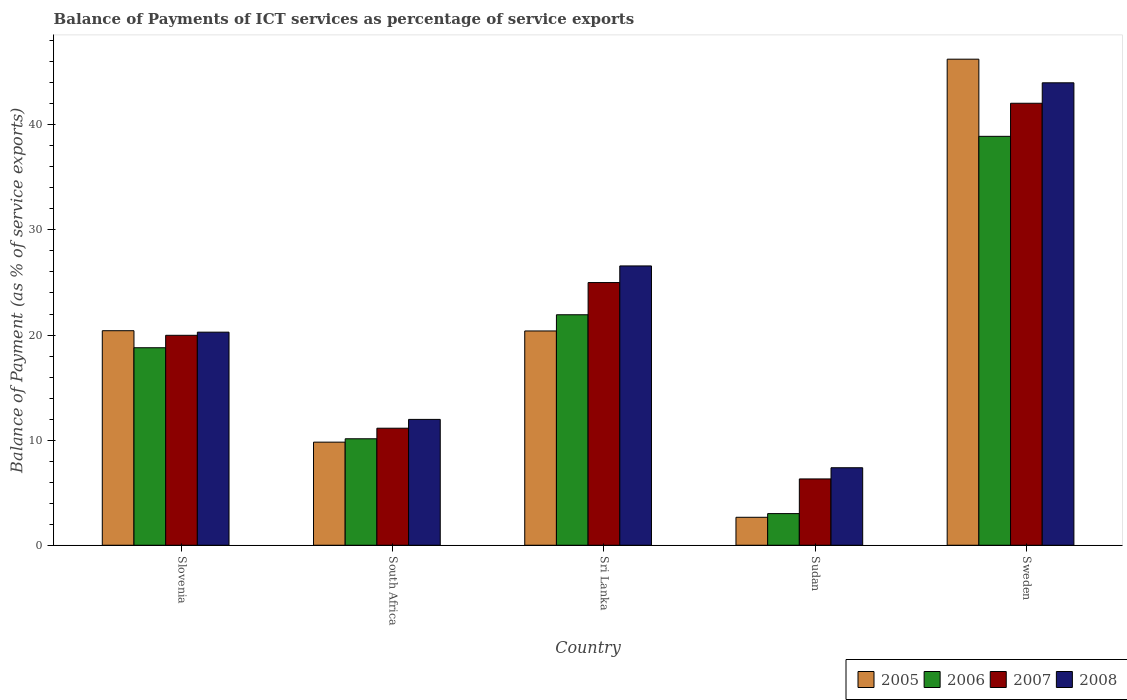Are the number of bars on each tick of the X-axis equal?
Ensure brevity in your answer.  Yes. How many bars are there on the 4th tick from the left?
Your response must be concise. 4. In how many cases, is the number of bars for a given country not equal to the number of legend labels?
Keep it short and to the point. 0. What is the balance of payments of ICT services in 2007 in South Africa?
Your answer should be compact. 11.13. Across all countries, what is the maximum balance of payments of ICT services in 2007?
Offer a very short reply. 42.05. Across all countries, what is the minimum balance of payments of ICT services in 2007?
Offer a terse response. 6.31. In which country was the balance of payments of ICT services in 2008 maximum?
Make the answer very short. Sweden. In which country was the balance of payments of ICT services in 2006 minimum?
Make the answer very short. Sudan. What is the total balance of payments of ICT services in 2007 in the graph?
Ensure brevity in your answer.  104.46. What is the difference between the balance of payments of ICT services in 2008 in Sudan and that in Sweden?
Your answer should be compact. -36.62. What is the difference between the balance of payments of ICT services in 2005 in Sweden and the balance of payments of ICT services in 2006 in Sri Lanka?
Offer a terse response. 24.32. What is the average balance of payments of ICT services in 2005 per country?
Keep it short and to the point. 19.9. What is the difference between the balance of payments of ICT services of/in 2008 and balance of payments of ICT services of/in 2007 in Sudan?
Ensure brevity in your answer.  1.06. In how many countries, is the balance of payments of ICT services in 2008 greater than 8 %?
Provide a short and direct response. 4. What is the ratio of the balance of payments of ICT services in 2007 in South Africa to that in Sweden?
Provide a short and direct response. 0.26. What is the difference between the highest and the second highest balance of payments of ICT services in 2005?
Your answer should be very brief. 0.02. What is the difference between the highest and the lowest balance of payments of ICT services in 2008?
Offer a terse response. 36.62. In how many countries, is the balance of payments of ICT services in 2006 greater than the average balance of payments of ICT services in 2006 taken over all countries?
Offer a very short reply. 3. Is the sum of the balance of payments of ICT services in 2007 in South Africa and Sri Lanka greater than the maximum balance of payments of ICT services in 2008 across all countries?
Provide a succinct answer. No. Is it the case that in every country, the sum of the balance of payments of ICT services in 2005 and balance of payments of ICT services in 2007 is greater than the sum of balance of payments of ICT services in 2008 and balance of payments of ICT services in 2006?
Give a very brief answer. No. What does the 2nd bar from the right in Slovenia represents?
Your answer should be very brief. 2007. Is it the case that in every country, the sum of the balance of payments of ICT services in 2005 and balance of payments of ICT services in 2007 is greater than the balance of payments of ICT services in 2008?
Make the answer very short. Yes. How many countries are there in the graph?
Provide a succinct answer. 5. What is the difference between two consecutive major ticks on the Y-axis?
Offer a terse response. 10. Are the values on the major ticks of Y-axis written in scientific E-notation?
Your answer should be very brief. No. How many legend labels are there?
Provide a short and direct response. 4. What is the title of the graph?
Offer a very short reply. Balance of Payments of ICT services as percentage of service exports. Does "2007" appear as one of the legend labels in the graph?
Make the answer very short. Yes. What is the label or title of the X-axis?
Provide a succinct answer. Country. What is the label or title of the Y-axis?
Offer a terse response. Balance of Payment (as % of service exports). What is the Balance of Payment (as % of service exports) of 2005 in Slovenia?
Keep it short and to the point. 20.41. What is the Balance of Payment (as % of service exports) in 2006 in Slovenia?
Offer a very short reply. 18.79. What is the Balance of Payment (as % of service exports) of 2007 in Slovenia?
Your response must be concise. 19.97. What is the Balance of Payment (as % of service exports) of 2008 in Slovenia?
Your answer should be compact. 20.27. What is the Balance of Payment (as % of service exports) in 2005 in South Africa?
Your answer should be compact. 9.81. What is the Balance of Payment (as % of service exports) of 2006 in South Africa?
Ensure brevity in your answer.  10.13. What is the Balance of Payment (as % of service exports) in 2007 in South Africa?
Give a very brief answer. 11.13. What is the Balance of Payment (as % of service exports) of 2008 in South Africa?
Give a very brief answer. 11.97. What is the Balance of Payment (as % of service exports) of 2005 in Sri Lanka?
Give a very brief answer. 20.39. What is the Balance of Payment (as % of service exports) in 2006 in Sri Lanka?
Your response must be concise. 21.93. What is the Balance of Payment (as % of service exports) of 2007 in Sri Lanka?
Offer a very short reply. 24.99. What is the Balance of Payment (as % of service exports) in 2008 in Sri Lanka?
Your response must be concise. 26.57. What is the Balance of Payment (as % of service exports) of 2005 in Sudan?
Provide a short and direct response. 2.66. What is the Balance of Payment (as % of service exports) of 2006 in Sudan?
Ensure brevity in your answer.  3.01. What is the Balance of Payment (as % of service exports) in 2007 in Sudan?
Provide a short and direct response. 6.31. What is the Balance of Payment (as % of service exports) in 2008 in Sudan?
Your answer should be compact. 7.37. What is the Balance of Payment (as % of service exports) in 2005 in Sweden?
Your answer should be compact. 46.24. What is the Balance of Payment (as % of service exports) of 2006 in Sweden?
Your answer should be very brief. 38.9. What is the Balance of Payment (as % of service exports) of 2007 in Sweden?
Your answer should be compact. 42.05. What is the Balance of Payment (as % of service exports) in 2008 in Sweden?
Make the answer very short. 44. Across all countries, what is the maximum Balance of Payment (as % of service exports) in 2005?
Provide a short and direct response. 46.24. Across all countries, what is the maximum Balance of Payment (as % of service exports) in 2006?
Make the answer very short. 38.9. Across all countries, what is the maximum Balance of Payment (as % of service exports) in 2007?
Provide a short and direct response. 42.05. Across all countries, what is the maximum Balance of Payment (as % of service exports) of 2008?
Ensure brevity in your answer.  44. Across all countries, what is the minimum Balance of Payment (as % of service exports) in 2005?
Offer a terse response. 2.66. Across all countries, what is the minimum Balance of Payment (as % of service exports) in 2006?
Provide a short and direct response. 3.01. Across all countries, what is the minimum Balance of Payment (as % of service exports) of 2007?
Your response must be concise. 6.31. Across all countries, what is the minimum Balance of Payment (as % of service exports) of 2008?
Ensure brevity in your answer.  7.37. What is the total Balance of Payment (as % of service exports) in 2005 in the graph?
Give a very brief answer. 99.51. What is the total Balance of Payment (as % of service exports) of 2006 in the graph?
Your response must be concise. 92.76. What is the total Balance of Payment (as % of service exports) of 2007 in the graph?
Ensure brevity in your answer.  104.46. What is the total Balance of Payment (as % of service exports) in 2008 in the graph?
Make the answer very short. 110.19. What is the difference between the Balance of Payment (as % of service exports) of 2005 in Slovenia and that in South Africa?
Provide a succinct answer. 10.6. What is the difference between the Balance of Payment (as % of service exports) of 2006 in Slovenia and that in South Africa?
Offer a very short reply. 8.66. What is the difference between the Balance of Payment (as % of service exports) of 2007 in Slovenia and that in South Africa?
Your answer should be compact. 8.84. What is the difference between the Balance of Payment (as % of service exports) of 2008 in Slovenia and that in South Africa?
Make the answer very short. 8.3. What is the difference between the Balance of Payment (as % of service exports) of 2005 in Slovenia and that in Sri Lanka?
Ensure brevity in your answer.  0.02. What is the difference between the Balance of Payment (as % of service exports) in 2006 in Slovenia and that in Sri Lanka?
Your answer should be compact. -3.14. What is the difference between the Balance of Payment (as % of service exports) of 2007 in Slovenia and that in Sri Lanka?
Make the answer very short. -5.02. What is the difference between the Balance of Payment (as % of service exports) in 2008 in Slovenia and that in Sri Lanka?
Your answer should be very brief. -6.3. What is the difference between the Balance of Payment (as % of service exports) in 2005 in Slovenia and that in Sudan?
Your answer should be compact. 17.75. What is the difference between the Balance of Payment (as % of service exports) in 2006 in Slovenia and that in Sudan?
Offer a terse response. 15.78. What is the difference between the Balance of Payment (as % of service exports) in 2007 in Slovenia and that in Sudan?
Provide a short and direct response. 13.66. What is the difference between the Balance of Payment (as % of service exports) of 2008 in Slovenia and that in Sudan?
Make the answer very short. 12.9. What is the difference between the Balance of Payment (as % of service exports) in 2005 in Slovenia and that in Sweden?
Offer a terse response. -25.83. What is the difference between the Balance of Payment (as % of service exports) in 2006 in Slovenia and that in Sweden?
Offer a very short reply. -20.11. What is the difference between the Balance of Payment (as % of service exports) of 2007 in Slovenia and that in Sweden?
Your answer should be compact. -22.08. What is the difference between the Balance of Payment (as % of service exports) of 2008 in Slovenia and that in Sweden?
Keep it short and to the point. -23.72. What is the difference between the Balance of Payment (as % of service exports) in 2005 in South Africa and that in Sri Lanka?
Offer a very short reply. -10.58. What is the difference between the Balance of Payment (as % of service exports) of 2006 in South Africa and that in Sri Lanka?
Provide a short and direct response. -11.8. What is the difference between the Balance of Payment (as % of service exports) of 2007 in South Africa and that in Sri Lanka?
Provide a short and direct response. -13.86. What is the difference between the Balance of Payment (as % of service exports) of 2008 in South Africa and that in Sri Lanka?
Provide a short and direct response. -14.6. What is the difference between the Balance of Payment (as % of service exports) in 2005 in South Africa and that in Sudan?
Your answer should be very brief. 7.15. What is the difference between the Balance of Payment (as % of service exports) in 2006 in South Africa and that in Sudan?
Give a very brief answer. 7.12. What is the difference between the Balance of Payment (as % of service exports) in 2007 in South Africa and that in Sudan?
Offer a very short reply. 4.83. What is the difference between the Balance of Payment (as % of service exports) in 2008 in South Africa and that in Sudan?
Your response must be concise. 4.6. What is the difference between the Balance of Payment (as % of service exports) of 2005 in South Africa and that in Sweden?
Your answer should be very brief. -36.44. What is the difference between the Balance of Payment (as % of service exports) of 2006 in South Africa and that in Sweden?
Make the answer very short. -28.77. What is the difference between the Balance of Payment (as % of service exports) in 2007 in South Africa and that in Sweden?
Your answer should be very brief. -30.92. What is the difference between the Balance of Payment (as % of service exports) in 2008 in South Africa and that in Sweden?
Your response must be concise. -32.02. What is the difference between the Balance of Payment (as % of service exports) of 2005 in Sri Lanka and that in Sudan?
Keep it short and to the point. 17.73. What is the difference between the Balance of Payment (as % of service exports) in 2006 in Sri Lanka and that in Sudan?
Provide a short and direct response. 18.92. What is the difference between the Balance of Payment (as % of service exports) in 2007 in Sri Lanka and that in Sudan?
Provide a succinct answer. 18.68. What is the difference between the Balance of Payment (as % of service exports) in 2008 in Sri Lanka and that in Sudan?
Your response must be concise. 19.2. What is the difference between the Balance of Payment (as % of service exports) of 2005 in Sri Lanka and that in Sweden?
Ensure brevity in your answer.  -25.86. What is the difference between the Balance of Payment (as % of service exports) of 2006 in Sri Lanka and that in Sweden?
Your answer should be compact. -16.98. What is the difference between the Balance of Payment (as % of service exports) in 2007 in Sri Lanka and that in Sweden?
Provide a short and direct response. -17.06. What is the difference between the Balance of Payment (as % of service exports) in 2008 in Sri Lanka and that in Sweden?
Give a very brief answer. -17.42. What is the difference between the Balance of Payment (as % of service exports) in 2005 in Sudan and that in Sweden?
Offer a terse response. -43.58. What is the difference between the Balance of Payment (as % of service exports) in 2006 in Sudan and that in Sweden?
Your answer should be very brief. -35.89. What is the difference between the Balance of Payment (as % of service exports) in 2007 in Sudan and that in Sweden?
Ensure brevity in your answer.  -35.74. What is the difference between the Balance of Payment (as % of service exports) of 2008 in Sudan and that in Sweden?
Your answer should be compact. -36.62. What is the difference between the Balance of Payment (as % of service exports) in 2005 in Slovenia and the Balance of Payment (as % of service exports) in 2006 in South Africa?
Provide a short and direct response. 10.28. What is the difference between the Balance of Payment (as % of service exports) in 2005 in Slovenia and the Balance of Payment (as % of service exports) in 2007 in South Africa?
Give a very brief answer. 9.28. What is the difference between the Balance of Payment (as % of service exports) in 2005 in Slovenia and the Balance of Payment (as % of service exports) in 2008 in South Africa?
Provide a short and direct response. 8.44. What is the difference between the Balance of Payment (as % of service exports) of 2006 in Slovenia and the Balance of Payment (as % of service exports) of 2007 in South Africa?
Ensure brevity in your answer.  7.66. What is the difference between the Balance of Payment (as % of service exports) of 2006 in Slovenia and the Balance of Payment (as % of service exports) of 2008 in South Africa?
Keep it short and to the point. 6.82. What is the difference between the Balance of Payment (as % of service exports) of 2007 in Slovenia and the Balance of Payment (as % of service exports) of 2008 in South Africa?
Keep it short and to the point. 8. What is the difference between the Balance of Payment (as % of service exports) in 2005 in Slovenia and the Balance of Payment (as % of service exports) in 2006 in Sri Lanka?
Your answer should be compact. -1.52. What is the difference between the Balance of Payment (as % of service exports) of 2005 in Slovenia and the Balance of Payment (as % of service exports) of 2007 in Sri Lanka?
Your answer should be very brief. -4.58. What is the difference between the Balance of Payment (as % of service exports) of 2005 in Slovenia and the Balance of Payment (as % of service exports) of 2008 in Sri Lanka?
Offer a very short reply. -6.16. What is the difference between the Balance of Payment (as % of service exports) of 2006 in Slovenia and the Balance of Payment (as % of service exports) of 2007 in Sri Lanka?
Offer a terse response. -6.2. What is the difference between the Balance of Payment (as % of service exports) of 2006 in Slovenia and the Balance of Payment (as % of service exports) of 2008 in Sri Lanka?
Give a very brief answer. -7.78. What is the difference between the Balance of Payment (as % of service exports) of 2007 in Slovenia and the Balance of Payment (as % of service exports) of 2008 in Sri Lanka?
Offer a terse response. -6.6. What is the difference between the Balance of Payment (as % of service exports) of 2005 in Slovenia and the Balance of Payment (as % of service exports) of 2006 in Sudan?
Your answer should be very brief. 17.4. What is the difference between the Balance of Payment (as % of service exports) in 2005 in Slovenia and the Balance of Payment (as % of service exports) in 2007 in Sudan?
Your answer should be very brief. 14.1. What is the difference between the Balance of Payment (as % of service exports) of 2005 in Slovenia and the Balance of Payment (as % of service exports) of 2008 in Sudan?
Keep it short and to the point. 13.04. What is the difference between the Balance of Payment (as % of service exports) of 2006 in Slovenia and the Balance of Payment (as % of service exports) of 2007 in Sudan?
Give a very brief answer. 12.48. What is the difference between the Balance of Payment (as % of service exports) in 2006 in Slovenia and the Balance of Payment (as % of service exports) in 2008 in Sudan?
Give a very brief answer. 11.42. What is the difference between the Balance of Payment (as % of service exports) in 2007 in Slovenia and the Balance of Payment (as % of service exports) in 2008 in Sudan?
Ensure brevity in your answer.  12.6. What is the difference between the Balance of Payment (as % of service exports) of 2005 in Slovenia and the Balance of Payment (as % of service exports) of 2006 in Sweden?
Ensure brevity in your answer.  -18.49. What is the difference between the Balance of Payment (as % of service exports) in 2005 in Slovenia and the Balance of Payment (as % of service exports) in 2007 in Sweden?
Your response must be concise. -21.64. What is the difference between the Balance of Payment (as % of service exports) in 2005 in Slovenia and the Balance of Payment (as % of service exports) in 2008 in Sweden?
Give a very brief answer. -23.59. What is the difference between the Balance of Payment (as % of service exports) in 2006 in Slovenia and the Balance of Payment (as % of service exports) in 2007 in Sweden?
Provide a short and direct response. -23.26. What is the difference between the Balance of Payment (as % of service exports) of 2006 in Slovenia and the Balance of Payment (as % of service exports) of 2008 in Sweden?
Provide a short and direct response. -25.21. What is the difference between the Balance of Payment (as % of service exports) in 2007 in Slovenia and the Balance of Payment (as % of service exports) in 2008 in Sweden?
Ensure brevity in your answer.  -24.02. What is the difference between the Balance of Payment (as % of service exports) of 2005 in South Africa and the Balance of Payment (as % of service exports) of 2006 in Sri Lanka?
Provide a succinct answer. -12.12. What is the difference between the Balance of Payment (as % of service exports) of 2005 in South Africa and the Balance of Payment (as % of service exports) of 2007 in Sri Lanka?
Offer a very short reply. -15.18. What is the difference between the Balance of Payment (as % of service exports) of 2005 in South Africa and the Balance of Payment (as % of service exports) of 2008 in Sri Lanka?
Offer a very short reply. -16.76. What is the difference between the Balance of Payment (as % of service exports) in 2006 in South Africa and the Balance of Payment (as % of service exports) in 2007 in Sri Lanka?
Ensure brevity in your answer.  -14.86. What is the difference between the Balance of Payment (as % of service exports) of 2006 in South Africa and the Balance of Payment (as % of service exports) of 2008 in Sri Lanka?
Provide a succinct answer. -16.44. What is the difference between the Balance of Payment (as % of service exports) in 2007 in South Africa and the Balance of Payment (as % of service exports) in 2008 in Sri Lanka?
Offer a terse response. -15.44. What is the difference between the Balance of Payment (as % of service exports) in 2005 in South Africa and the Balance of Payment (as % of service exports) in 2006 in Sudan?
Provide a succinct answer. 6.8. What is the difference between the Balance of Payment (as % of service exports) in 2005 in South Africa and the Balance of Payment (as % of service exports) in 2007 in Sudan?
Offer a terse response. 3.5. What is the difference between the Balance of Payment (as % of service exports) in 2005 in South Africa and the Balance of Payment (as % of service exports) in 2008 in Sudan?
Offer a very short reply. 2.44. What is the difference between the Balance of Payment (as % of service exports) of 2006 in South Africa and the Balance of Payment (as % of service exports) of 2007 in Sudan?
Ensure brevity in your answer.  3.82. What is the difference between the Balance of Payment (as % of service exports) of 2006 in South Africa and the Balance of Payment (as % of service exports) of 2008 in Sudan?
Offer a terse response. 2.76. What is the difference between the Balance of Payment (as % of service exports) of 2007 in South Africa and the Balance of Payment (as % of service exports) of 2008 in Sudan?
Your answer should be compact. 3.76. What is the difference between the Balance of Payment (as % of service exports) of 2005 in South Africa and the Balance of Payment (as % of service exports) of 2006 in Sweden?
Make the answer very short. -29.09. What is the difference between the Balance of Payment (as % of service exports) of 2005 in South Africa and the Balance of Payment (as % of service exports) of 2007 in Sweden?
Give a very brief answer. -32.24. What is the difference between the Balance of Payment (as % of service exports) of 2005 in South Africa and the Balance of Payment (as % of service exports) of 2008 in Sweden?
Your answer should be very brief. -34.19. What is the difference between the Balance of Payment (as % of service exports) of 2006 in South Africa and the Balance of Payment (as % of service exports) of 2007 in Sweden?
Your answer should be very brief. -31.92. What is the difference between the Balance of Payment (as % of service exports) of 2006 in South Africa and the Balance of Payment (as % of service exports) of 2008 in Sweden?
Make the answer very short. -33.87. What is the difference between the Balance of Payment (as % of service exports) in 2007 in South Africa and the Balance of Payment (as % of service exports) in 2008 in Sweden?
Provide a succinct answer. -32.86. What is the difference between the Balance of Payment (as % of service exports) in 2005 in Sri Lanka and the Balance of Payment (as % of service exports) in 2006 in Sudan?
Your answer should be compact. 17.38. What is the difference between the Balance of Payment (as % of service exports) in 2005 in Sri Lanka and the Balance of Payment (as % of service exports) in 2007 in Sudan?
Make the answer very short. 14.08. What is the difference between the Balance of Payment (as % of service exports) of 2005 in Sri Lanka and the Balance of Payment (as % of service exports) of 2008 in Sudan?
Keep it short and to the point. 13.01. What is the difference between the Balance of Payment (as % of service exports) in 2006 in Sri Lanka and the Balance of Payment (as % of service exports) in 2007 in Sudan?
Offer a very short reply. 15.62. What is the difference between the Balance of Payment (as % of service exports) of 2006 in Sri Lanka and the Balance of Payment (as % of service exports) of 2008 in Sudan?
Offer a very short reply. 14.55. What is the difference between the Balance of Payment (as % of service exports) of 2007 in Sri Lanka and the Balance of Payment (as % of service exports) of 2008 in Sudan?
Provide a short and direct response. 17.62. What is the difference between the Balance of Payment (as % of service exports) of 2005 in Sri Lanka and the Balance of Payment (as % of service exports) of 2006 in Sweden?
Provide a succinct answer. -18.52. What is the difference between the Balance of Payment (as % of service exports) in 2005 in Sri Lanka and the Balance of Payment (as % of service exports) in 2007 in Sweden?
Make the answer very short. -21.66. What is the difference between the Balance of Payment (as % of service exports) in 2005 in Sri Lanka and the Balance of Payment (as % of service exports) in 2008 in Sweden?
Provide a succinct answer. -23.61. What is the difference between the Balance of Payment (as % of service exports) in 2006 in Sri Lanka and the Balance of Payment (as % of service exports) in 2007 in Sweden?
Your answer should be very brief. -20.12. What is the difference between the Balance of Payment (as % of service exports) of 2006 in Sri Lanka and the Balance of Payment (as % of service exports) of 2008 in Sweden?
Keep it short and to the point. -22.07. What is the difference between the Balance of Payment (as % of service exports) in 2007 in Sri Lanka and the Balance of Payment (as % of service exports) in 2008 in Sweden?
Make the answer very short. -19. What is the difference between the Balance of Payment (as % of service exports) of 2005 in Sudan and the Balance of Payment (as % of service exports) of 2006 in Sweden?
Make the answer very short. -36.24. What is the difference between the Balance of Payment (as % of service exports) in 2005 in Sudan and the Balance of Payment (as % of service exports) in 2007 in Sweden?
Your response must be concise. -39.39. What is the difference between the Balance of Payment (as % of service exports) of 2005 in Sudan and the Balance of Payment (as % of service exports) of 2008 in Sweden?
Your answer should be very brief. -41.34. What is the difference between the Balance of Payment (as % of service exports) of 2006 in Sudan and the Balance of Payment (as % of service exports) of 2007 in Sweden?
Make the answer very short. -39.04. What is the difference between the Balance of Payment (as % of service exports) in 2006 in Sudan and the Balance of Payment (as % of service exports) in 2008 in Sweden?
Your answer should be very brief. -40.99. What is the difference between the Balance of Payment (as % of service exports) in 2007 in Sudan and the Balance of Payment (as % of service exports) in 2008 in Sweden?
Provide a succinct answer. -37.69. What is the average Balance of Payment (as % of service exports) in 2005 per country?
Your answer should be very brief. 19.9. What is the average Balance of Payment (as % of service exports) in 2006 per country?
Give a very brief answer. 18.55. What is the average Balance of Payment (as % of service exports) in 2007 per country?
Ensure brevity in your answer.  20.89. What is the average Balance of Payment (as % of service exports) of 2008 per country?
Provide a short and direct response. 22.04. What is the difference between the Balance of Payment (as % of service exports) in 2005 and Balance of Payment (as % of service exports) in 2006 in Slovenia?
Give a very brief answer. 1.62. What is the difference between the Balance of Payment (as % of service exports) of 2005 and Balance of Payment (as % of service exports) of 2007 in Slovenia?
Make the answer very short. 0.44. What is the difference between the Balance of Payment (as % of service exports) in 2005 and Balance of Payment (as % of service exports) in 2008 in Slovenia?
Your answer should be very brief. 0.14. What is the difference between the Balance of Payment (as % of service exports) in 2006 and Balance of Payment (as % of service exports) in 2007 in Slovenia?
Give a very brief answer. -1.18. What is the difference between the Balance of Payment (as % of service exports) in 2006 and Balance of Payment (as % of service exports) in 2008 in Slovenia?
Ensure brevity in your answer.  -1.48. What is the difference between the Balance of Payment (as % of service exports) of 2007 and Balance of Payment (as % of service exports) of 2008 in Slovenia?
Offer a very short reply. -0.3. What is the difference between the Balance of Payment (as % of service exports) in 2005 and Balance of Payment (as % of service exports) in 2006 in South Africa?
Your answer should be compact. -0.32. What is the difference between the Balance of Payment (as % of service exports) in 2005 and Balance of Payment (as % of service exports) in 2007 in South Africa?
Make the answer very short. -1.33. What is the difference between the Balance of Payment (as % of service exports) in 2005 and Balance of Payment (as % of service exports) in 2008 in South Africa?
Make the answer very short. -2.16. What is the difference between the Balance of Payment (as % of service exports) of 2006 and Balance of Payment (as % of service exports) of 2007 in South Africa?
Your response must be concise. -1. What is the difference between the Balance of Payment (as % of service exports) in 2006 and Balance of Payment (as % of service exports) in 2008 in South Africa?
Your answer should be very brief. -1.84. What is the difference between the Balance of Payment (as % of service exports) in 2007 and Balance of Payment (as % of service exports) in 2008 in South Africa?
Give a very brief answer. -0.84. What is the difference between the Balance of Payment (as % of service exports) of 2005 and Balance of Payment (as % of service exports) of 2006 in Sri Lanka?
Make the answer very short. -1.54. What is the difference between the Balance of Payment (as % of service exports) of 2005 and Balance of Payment (as % of service exports) of 2007 in Sri Lanka?
Keep it short and to the point. -4.61. What is the difference between the Balance of Payment (as % of service exports) of 2005 and Balance of Payment (as % of service exports) of 2008 in Sri Lanka?
Make the answer very short. -6.19. What is the difference between the Balance of Payment (as % of service exports) of 2006 and Balance of Payment (as % of service exports) of 2007 in Sri Lanka?
Make the answer very short. -3.06. What is the difference between the Balance of Payment (as % of service exports) in 2006 and Balance of Payment (as % of service exports) in 2008 in Sri Lanka?
Keep it short and to the point. -4.65. What is the difference between the Balance of Payment (as % of service exports) of 2007 and Balance of Payment (as % of service exports) of 2008 in Sri Lanka?
Provide a succinct answer. -1.58. What is the difference between the Balance of Payment (as % of service exports) of 2005 and Balance of Payment (as % of service exports) of 2006 in Sudan?
Give a very brief answer. -0.35. What is the difference between the Balance of Payment (as % of service exports) of 2005 and Balance of Payment (as % of service exports) of 2007 in Sudan?
Provide a short and direct response. -3.65. What is the difference between the Balance of Payment (as % of service exports) in 2005 and Balance of Payment (as % of service exports) in 2008 in Sudan?
Offer a terse response. -4.71. What is the difference between the Balance of Payment (as % of service exports) of 2006 and Balance of Payment (as % of service exports) of 2007 in Sudan?
Offer a terse response. -3.3. What is the difference between the Balance of Payment (as % of service exports) in 2006 and Balance of Payment (as % of service exports) in 2008 in Sudan?
Your response must be concise. -4.36. What is the difference between the Balance of Payment (as % of service exports) of 2007 and Balance of Payment (as % of service exports) of 2008 in Sudan?
Your answer should be compact. -1.06. What is the difference between the Balance of Payment (as % of service exports) in 2005 and Balance of Payment (as % of service exports) in 2006 in Sweden?
Keep it short and to the point. 7.34. What is the difference between the Balance of Payment (as % of service exports) in 2005 and Balance of Payment (as % of service exports) in 2007 in Sweden?
Make the answer very short. 4.19. What is the difference between the Balance of Payment (as % of service exports) of 2005 and Balance of Payment (as % of service exports) of 2008 in Sweden?
Your response must be concise. 2.25. What is the difference between the Balance of Payment (as % of service exports) of 2006 and Balance of Payment (as % of service exports) of 2007 in Sweden?
Your response must be concise. -3.15. What is the difference between the Balance of Payment (as % of service exports) of 2006 and Balance of Payment (as % of service exports) of 2008 in Sweden?
Give a very brief answer. -5.09. What is the difference between the Balance of Payment (as % of service exports) in 2007 and Balance of Payment (as % of service exports) in 2008 in Sweden?
Provide a short and direct response. -1.95. What is the ratio of the Balance of Payment (as % of service exports) of 2005 in Slovenia to that in South Africa?
Make the answer very short. 2.08. What is the ratio of the Balance of Payment (as % of service exports) of 2006 in Slovenia to that in South Africa?
Give a very brief answer. 1.86. What is the ratio of the Balance of Payment (as % of service exports) in 2007 in Slovenia to that in South Africa?
Your response must be concise. 1.79. What is the ratio of the Balance of Payment (as % of service exports) in 2008 in Slovenia to that in South Africa?
Make the answer very short. 1.69. What is the ratio of the Balance of Payment (as % of service exports) in 2005 in Slovenia to that in Sri Lanka?
Provide a short and direct response. 1. What is the ratio of the Balance of Payment (as % of service exports) in 2006 in Slovenia to that in Sri Lanka?
Provide a succinct answer. 0.86. What is the ratio of the Balance of Payment (as % of service exports) in 2007 in Slovenia to that in Sri Lanka?
Provide a succinct answer. 0.8. What is the ratio of the Balance of Payment (as % of service exports) in 2008 in Slovenia to that in Sri Lanka?
Offer a very short reply. 0.76. What is the ratio of the Balance of Payment (as % of service exports) of 2005 in Slovenia to that in Sudan?
Provide a succinct answer. 7.67. What is the ratio of the Balance of Payment (as % of service exports) in 2006 in Slovenia to that in Sudan?
Your answer should be very brief. 6.24. What is the ratio of the Balance of Payment (as % of service exports) in 2007 in Slovenia to that in Sudan?
Offer a very short reply. 3.17. What is the ratio of the Balance of Payment (as % of service exports) in 2008 in Slovenia to that in Sudan?
Make the answer very short. 2.75. What is the ratio of the Balance of Payment (as % of service exports) in 2005 in Slovenia to that in Sweden?
Provide a short and direct response. 0.44. What is the ratio of the Balance of Payment (as % of service exports) of 2006 in Slovenia to that in Sweden?
Your answer should be compact. 0.48. What is the ratio of the Balance of Payment (as % of service exports) of 2007 in Slovenia to that in Sweden?
Your answer should be compact. 0.47. What is the ratio of the Balance of Payment (as % of service exports) of 2008 in Slovenia to that in Sweden?
Ensure brevity in your answer.  0.46. What is the ratio of the Balance of Payment (as % of service exports) in 2005 in South Africa to that in Sri Lanka?
Your response must be concise. 0.48. What is the ratio of the Balance of Payment (as % of service exports) of 2006 in South Africa to that in Sri Lanka?
Provide a succinct answer. 0.46. What is the ratio of the Balance of Payment (as % of service exports) in 2007 in South Africa to that in Sri Lanka?
Your answer should be compact. 0.45. What is the ratio of the Balance of Payment (as % of service exports) in 2008 in South Africa to that in Sri Lanka?
Keep it short and to the point. 0.45. What is the ratio of the Balance of Payment (as % of service exports) of 2005 in South Africa to that in Sudan?
Your response must be concise. 3.69. What is the ratio of the Balance of Payment (as % of service exports) of 2006 in South Africa to that in Sudan?
Offer a very short reply. 3.37. What is the ratio of the Balance of Payment (as % of service exports) of 2007 in South Africa to that in Sudan?
Provide a short and direct response. 1.76. What is the ratio of the Balance of Payment (as % of service exports) in 2008 in South Africa to that in Sudan?
Offer a terse response. 1.62. What is the ratio of the Balance of Payment (as % of service exports) of 2005 in South Africa to that in Sweden?
Provide a succinct answer. 0.21. What is the ratio of the Balance of Payment (as % of service exports) in 2006 in South Africa to that in Sweden?
Provide a short and direct response. 0.26. What is the ratio of the Balance of Payment (as % of service exports) of 2007 in South Africa to that in Sweden?
Your response must be concise. 0.26. What is the ratio of the Balance of Payment (as % of service exports) of 2008 in South Africa to that in Sweden?
Give a very brief answer. 0.27. What is the ratio of the Balance of Payment (as % of service exports) in 2005 in Sri Lanka to that in Sudan?
Offer a very short reply. 7.67. What is the ratio of the Balance of Payment (as % of service exports) in 2006 in Sri Lanka to that in Sudan?
Offer a very short reply. 7.29. What is the ratio of the Balance of Payment (as % of service exports) of 2007 in Sri Lanka to that in Sudan?
Your answer should be compact. 3.96. What is the ratio of the Balance of Payment (as % of service exports) of 2008 in Sri Lanka to that in Sudan?
Your response must be concise. 3.6. What is the ratio of the Balance of Payment (as % of service exports) of 2005 in Sri Lanka to that in Sweden?
Ensure brevity in your answer.  0.44. What is the ratio of the Balance of Payment (as % of service exports) of 2006 in Sri Lanka to that in Sweden?
Provide a short and direct response. 0.56. What is the ratio of the Balance of Payment (as % of service exports) in 2007 in Sri Lanka to that in Sweden?
Provide a short and direct response. 0.59. What is the ratio of the Balance of Payment (as % of service exports) in 2008 in Sri Lanka to that in Sweden?
Offer a terse response. 0.6. What is the ratio of the Balance of Payment (as % of service exports) in 2005 in Sudan to that in Sweden?
Offer a terse response. 0.06. What is the ratio of the Balance of Payment (as % of service exports) of 2006 in Sudan to that in Sweden?
Your answer should be very brief. 0.08. What is the ratio of the Balance of Payment (as % of service exports) of 2008 in Sudan to that in Sweden?
Provide a succinct answer. 0.17. What is the difference between the highest and the second highest Balance of Payment (as % of service exports) in 2005?
Make the answer very short. 25.83. What is the difference between the highest and the second highest Balance of Payment (as % of service exports) in 2006?
Your answer should be very brief. 16.98. What is the difference between the highest and the second highest Balance of Payment (as % of service exports) of 2007?
Provide a short and direct response. 17.06. What is the difference between the highest and the second highest Balance of Payment (as % of service exports) of 2008?
Your answer should be very brief. 17.42. What is the difference between the highest and the lowest Balance of Payment (as % of service exports) in 2005?
Give a very brief answer. 43.58. What is the difference between the highest and the lowest Balance of Payment (as % of service exports) in 2006?
Provide a succinct answer. 35.89. What is the difference between the highest and the lowest Balance of Payment (as % of service exports) in 2007?
Make the answer very short. 35.74. What is the difference between the highest and the lowest Balance of Payment (as % of service exports) in 2008?
Offer a terse response. 36.62. 